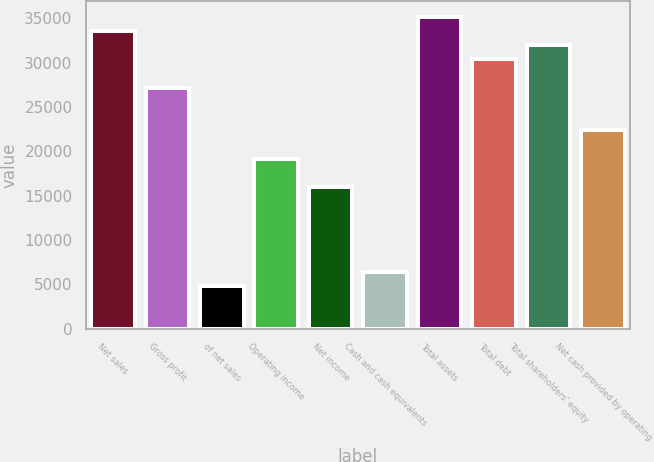<chart> <loc_0><loc_0><loc_500><loc_500><bar_chart><fcel>Net sales<fcel>Gross profit<fcel>of net sales<fcel>Operating income<fcel>Net income<fcel>Cash and cash equivalents<fcel>Total assets<fcel>Total debt<fcel>Total shareholders' equity<fcel>Net cash provided by operating<nl><fcel>33563.6<fcel>27171.1<fcel>4797.1<fcel>19180.4<fcel>15984.1<fcel>6395.24<fcel>35161.8<fcel>30367.3<fcel>31965.5<fcel>22376.6<nl></chart> 